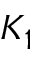Convert formula to latex. <formula><loc_0><loc_0><loc_500><loc_500>K _ { 1 }</formula> 